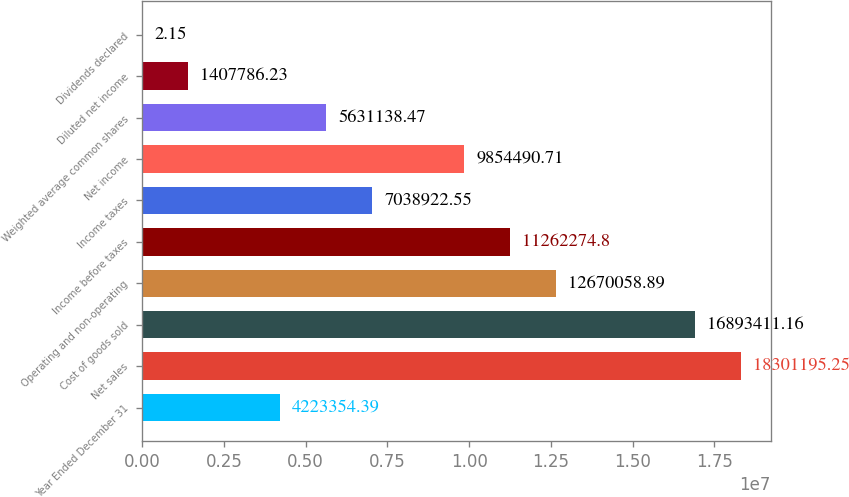Convert chart. <chart><loc_0><loc_0><loc_500><loc_500><bar_chart><fcel>Year Ended December 31<fcel>Net sales<fcel>Cost of goods sold<fcel>Operating and non-operating<fcel>Income before taxes<fcel>Income taxes<fcel>Net income<fcel>Weighted average common shares<fcel>Diluted net income<fcel>Dividends declared<nl><fcel>4.22335e+06<fcel>1.83012e+07<fcel>1.68934e+07<fcel>1.26701e+07<fcel>1.12623e+07<fcel>7.03892e+06<fcel>9.85449e+06<fcel>5.63114e+06<fcel>1.40779e+06<fcel>2.15<nl></chart> 